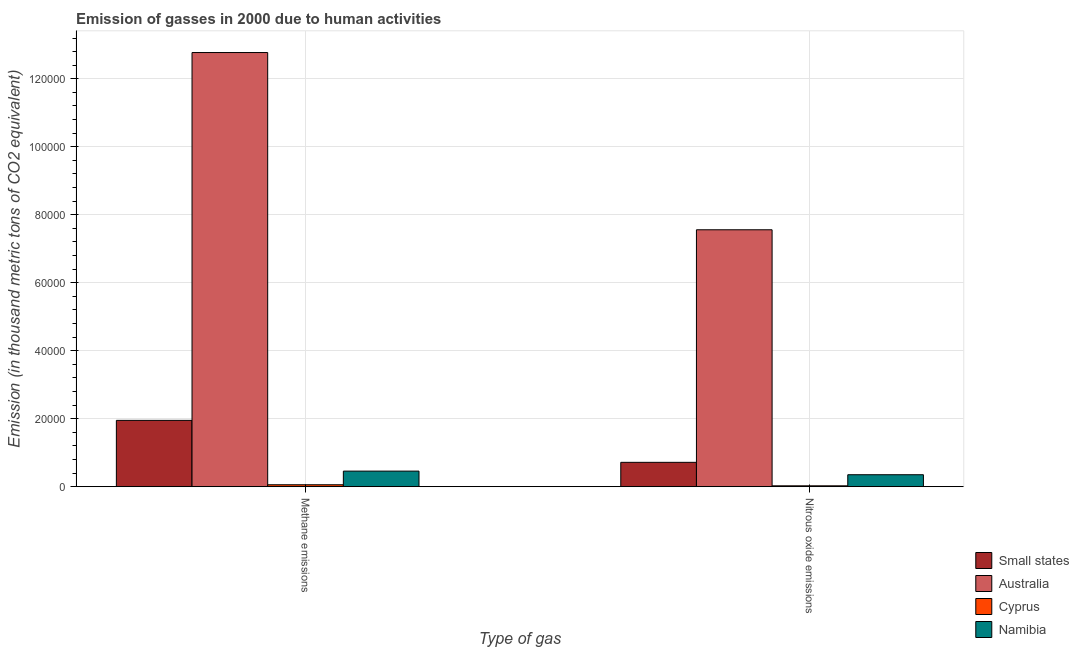How many groups of bars are there?
Provide a succinct answer. 2. Are the number of bars per tick equal to the number of legend labels?
Keep it short and to the point. Yes. What is the label of the 1st group of bars from the left?
Your answer should be very brief. Methane emissions. What is the amount of nitrous oxide emissions in Namibia?
Make the answer very short. 3518.5. Across all countries, what is the maximum amount of methane emissions?
Give a very brief answer. 1.28e+05. Across all countries, what is the minimum amount of methane emissions?
Make the answer very short. 569.2. In which country was the amount of methane emissions maximum?
Ensure brevity in your answer.  Australia. In which country was the amount of methane emissions minimum?
Your answer should be very brief. Cyprus. What is the total amount of nitrous oxide emissions in the graph?
Keep it short and to the point. 8.65e+04. What is the difference between the amount of nitrous oxide emissions in Namibia and that in Cyprus?
Keep it short and to the point. 3262.6. What is the difference between the amount of nitrous oxide emissions in Cyprus and the amount of methane emissions in Small states?
Ensure brevity in your answer.  -1.93e+04. What is the average amount of nitrous oxide emissions per country?
Provide a short and direct response. 2.16e+04. What is the difference between the amount of nitrous oxide emissions and amount of methane emissions in Australia?
Provide a short and direct response. -5.21e+04. What is the ratio of the amount of nitrous oxide emissions in Namibia to that in Small states?
Provide a short and direct response. 0.49. In how many countries, is the amount of methane emissions greater than the average amount of methane emissions taken over all countries?
Make the answer very short. 1. What does the 3rd bar from the left in Nitrous oxide emissions represents?
Offer a very short reply. Cyprus. What does the 1st bar from the right in Nitrous oxide emissions represents?
Make the answer very short. Namibia. How many bars are there?
Offer a terse response. 8. Are all the bars in the graph horizontal?
Offer a very short reply. No. Are the values on the major ticks of Y-axis written in scientific E-notation?
Provide a succinct answer. No. Does the graph contain any zero values?
Keep it short and to the point. No. Does the graph contain grids?
Provide a succinct answer. Yes. Where does the legend appear in the graph?
Your response must be concise. Bottom right. How are the legend labels stacked?
Your answer should be very brief. Vertical. What is the title of the graph?
Provide a succinct answer. Emission of gasses in 2000 due to human activities. What is the label or title of the X-axis?
Ensure brevity in your answer.  Type of gas. What is the label or title of the Y-axis?
Provide a succinct answer. Emission (in thousand metric tons of CO2 equivalent). What is the Emission (in thousand metric tons of CO2 equivalent) in Small states in Methane emissions?
Offer a terse response. 1.95e+04. What is the Emission (in thousand metric tons of CO2 equivalent) in Australia in Methane emissions?
Your answer should be compact. 1.28e+05. What is the Emission (in thousand metric tons of CO2 equivalent) of Cyprus in Methane emissions?
Give a very brief answer. 569.2. What is the Emission (in thousand metric tons of CO2 equivalent) of Namibia in Methane emissions?
Your answer should be compact. 4581.7. What is the Emission (in thousand metric tons of CO2 equivalent) in Small states in Nitrous oxide emissions?
Your answer should be very brief. 7164.7. What is the Emission (in thousand metric tons of CO2 equivalent) in Australia in Nitrous oxide emissions?
Make the answer very short. 7.56e+04. What is the Emission (in thousand metric tons of CO2 equivalent) in Cyprus in Nitrous oxide emissions?
Offer a terse response. 255.9. What is the Emission (in thousand metric tons of CO2 equivalent) in Namibia in Nitrous oxide emissions?
Your answer should be very brief. 3518.5. Across all Type of gas, what is the maximum Emission (in thousand metric tons of CO2 equivalent) of Small states?
Keep it short and to the point. 1.95e+04. Across all Type of gas, what is the maximum Emission (in thousand metric tons of CO2 equivalent) of Australia?
Provide a succinct answer. 1.28e+05. Across all Type of gas, what is the maximum Emission (in thousand metric tons of CO2 equivalent) of Cyprus?
Ensure brevity in your answer.  569.2. Across all Type of gas, what is the maximum Emission (in thousand metric tons of CO2 equivalent) of Namibia?
Your answer should be compact. 4581.7. Across all Type of gas, what is the minimum Emission (in thousand metric tons of CO2 equivalent) in Small states?
Offer a terse response. 7164.7. Across all Type of gas, what is the minimum Emission (in thousand metric tons of CO2 equivalent) in Australia?
Offer a very short reply. 7.56e+04. Across all Type of gas, what is the minimum Emission (in thousand metric tons of CO2 equivalent) in Cyprus?
Offer a terse response. 255.9. Across all Type of gas, what is the minimum Emission (in thousand metric tons of CO2 equivalent) in Namibia?
Ensure brevity in your answer.  3518.5. What is the total Emission (in thousand metric tons of CO2 equivalent) in Small states in the graph?
Offer a terse response. 2.67e+04. What is the total Emission (in thousand metric tons of CO2 equivalent) of Australia in the graph?
Keep it short and to the point. 2.03e+05. What is the total Emission (in thousand metric tons of CO2 equivalent) of Cyprus in the graph?
Offer a terse response. 825.1. What is the total Emission (in thousand metric tons of CO2 equivalent) in Namibia in the graph?
Make the answer very short. 8100.2. What is the difference between the Emission (in thousand metric tons of CO2 equivalent) of Small states in Methane emissions and that in Nitrous oxide emissions?
Keep it short and to the point. 1.23e+04. What is the difference between the Emission (in thousand metric tons of CO2 equivalent) of Australia in Methane emissions and that in Nitrous oxide emissions?
Your response must be concise. 5.21e+04. What is the difference between the Emission (in thousand metric tons of CO2 equivalent) in Cyprus in Methane emissions and that in Nitrous oxide emissions?
Your answer should be compact. 313.3. What is the difference between the Emission (in thousand metric tons of CO2 equivalent) of Namibia in Methane emissions and that in Nitrous oxide emissions?
Offer a very short reply. 1063.2. What is the difference between the Emission (in thousand metric tons of CO2 equivalent) in Small states in Methane emissions and the Emission (in thousand metric tons of CO2 equivalent) in Australia in Nitrous oxide emissions?
Make the answer very short. -5.61e+04. What is the difference between the Emission (in thousand metric tons of CO2 equivalent) of Small states in Methane emissions and the Emission (in thousand metric tons of CO2 equivalent) of Cyprus in Nitrous oxide emissions?
Provide a short and direct response. 1.93e+04. What is the difference between the Emission (in thousand metric tons of CO2 equivalent) in Small states in Methane emissions and the Emission (in thousand metric tons of CO2 equivalent) in Namibia in Nitrous oxide emissions?
Ensure brevity in your answer.  1.60e+04. What is the difference between the Emission (in thousand metric tons of CO2 equivalent) in Australia in Methane emissions and the Emission (in thousand metric tons of CO2 equivalent) in Cyprus in Nitrous oxide emissions?
Ensure brevity in your answer.  1.27e+05. What is the difference between the Emission (in thousand metric tons of CO2 equivalent) in Australia in Methane emissions and the Emission (in thousand metric tons of CO2 equivalent) in Namibia in Nitrous oxide emissions?
Offer a terse response. 1.24e+05. What is the difference between the Emission (in thousand metric tons of CO2 equivalent) in Cyprus in Methane emissions and the Emission (in thousand metric tons of CO2 equivalent) in Namibia in Nitrous oxide emissions?
Give a very brief answer. -2949.3. What is the average Emission (in thousand metric tons of CO2 equivalent) in Small states per Type of gas?
Ensure brevity in your answer.  1.33e+04. What is the average Emission (in thousand metric tons of CO2 equivalent) of Australia per Type of gas?
Offer a very short reply. 1.02e+05. What is the average Emission (in thousand metric tons of CO2 equivalent) of Cyprus per Type of gas?
Offer a terse response. 412.55. What is the average Emission (in thousand metric tons of CO2 equivalent) of Namibia per Type of gas?
Your answer should be very brief. 4050.1. What is the difference between the Emission (in thousand metric tons of CO2 equivalent) in Small states and Emission (in thousand metric tons of CO2 equivalent) in Australia in Methane emissions?
Give a very brief answer. -1.08e+05. What is the difference between the Emission (in thousand metric tons of CO2 equivalent) in Small states and Emission (in thousand metric tons of CO2 equivalent) in Cyprus in Methane emissions?
Offer a terse response. 1.89e+04. What is the difference between the Emission (in thousand metric tons of CO2 equivalent) of Small states and Emission (in thousand metric tons of CO2 equivalent) of Namibia in Methane emissions?
Offer a very short reply. 1.49e+04. What is the difference between the Emission (in thousand metric tons of CO2 equivalent) of Australia and Emission (in thousand metric tons of CO2 equivalent) of Cyprus in Methane emissions?
Ensure brevity in your answer.  1.27e+05. What is the difference between the Emission (in thousand metric tons of CO2 equivalent) of Australia and Emission (in thousand metric tons of CO2 equivalent) of Namibia in Methane emissions?
Provide a succinct answer. 1.23e+05. What is the difference between the Emission (in thousand metric tons of CO2 equivalent) of Cyprus and Emission (in thousand metric tons of CO2 equivalent) of Namibia in Methane emissions?
Offer a terse response. -4012.5. What is the difference between the Emission (in thousand metric tons of CO2 equivalent) of Small states and Emission (in thousand metric tons of CO2 equivalent) of Australia in Nitrous oxide emissions?
Keep it short and to the point. -6.84e+04. What is the difference between the Emission (in thousand metric tons of CO2 equivalent) of Small states and Emission (in thousand metric tons of CO2 equivalent) of Cyprus in Nitrous oxide emissions?
Keep it short and to the point. 6908.8. What is the difference between the Emission (in thousand metric tons of CO2 equivalent) of Small states and Emission (in thousand metric tons of CO2 equivalent) of Namibia in Nitrous oxide emissions?
Your answer should be compact. 3646.2. What is the difference between the Emission (in thousand metric tons of CO2 equivalent) of Australia and Emission (in thousand metric tons of CO2 equivalent) of Cyprus in Nitrous oxide emissions?
Your answer should be very brief. 7.53e+04. What is the difference between the Emission (in thousand metric tons of CO2 equivalent) in Australia and Emission (in thousand metric tons of CO2 equivalent) in Namibia in Nitrous oxide emissions?
Make the answer very short. 7.21e+04. What is the difference between the Emission (in thousand metric tons of CO2 equivalent) of Cyprus and Emission (in thousand metric tons of CO2 equivalent) of Namibia in Nitrous oxide emissions?
Ensure brevity in your answer.  -3262.6. What is the ratio of the Emission (in thousand metric tons of CO2 equivalent) of Small states in Methane emissions to that in Nitrous oxide emissions?
Your answer should be very brief. 2.72. What is the ratio of the Emission (in thousand metric tons of CO2 equivalent) in Australia in Methane emissions to that in Nitrous oxide emissions?
Your answer should be compact. 1.69. What is the ratio of the Emission (in thousand metric tons of CO2 equivalent) of Cyprus in Methane emissions to that in Nitrous oxide emissions?
Make the answer very short. 2.22. What is the ratio of the Emission (in thousand metric tons of CO2 equivalent) of Namibia in Methane emissions to that in Nitrous oxide emissions?
Provide a succinct answer. 1.3. What is the difference between the highest and the second highest Emission (in thousand metric tons of CO2 equivalent) in Small states?
Give a very brief answer. 1.23e+04. What is the difference between the highest and the second highest Emission (in thousand metric tons of CO2 equivalent) in Australia?
Keep it short and to the point. 5.21e+04. What is the difference between the highest and the second highest Emission (in thousand metric tons of CO2 equivalent) of Cyprus?
Provide a succinct answer. 313.3. What is the difference between the highest and the second highest Emission (in thousand metric tons of CO2 equivalent) of Namibia?
Keep it short and to the point. 1063.2. What is the difference between the highest and the lowest Emission (in thousand metric tons of CO2 equivalent) of Small states?
Offer a terse response. 1.23e+04. What is the difference between the highest and the lowest Emission (in thousand metric tons of CO2 equivalent) of Australia?
Give a very brief answer. 5.21e+04. What is the difference between the highest and the lowest Emission (in thousand metric tons of CO2 equivalent) in Cyprus?
Offer a very short reply. 313.3. What is the difference between the highest and the lowest Emission (in thousand metric tons of CO2 equivalent) of Namibia?
Offer a terse response. 1063.2. 